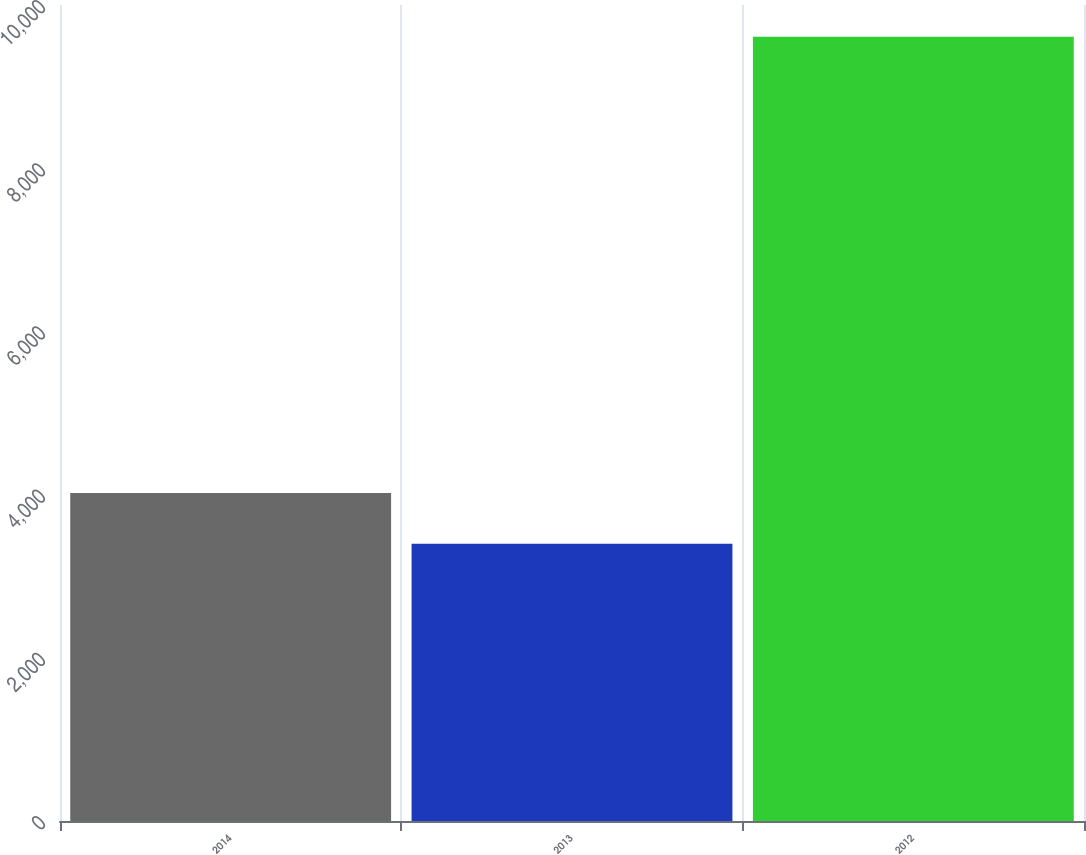Convert chart. <chart><loc_0><loc_0><loc_500><loc_500><bar_chart><fcel>2014<fcel>2013<fcel>2012<nl><fcel>4019.3<fcel>3398<fcel>9611<nl></chart> 